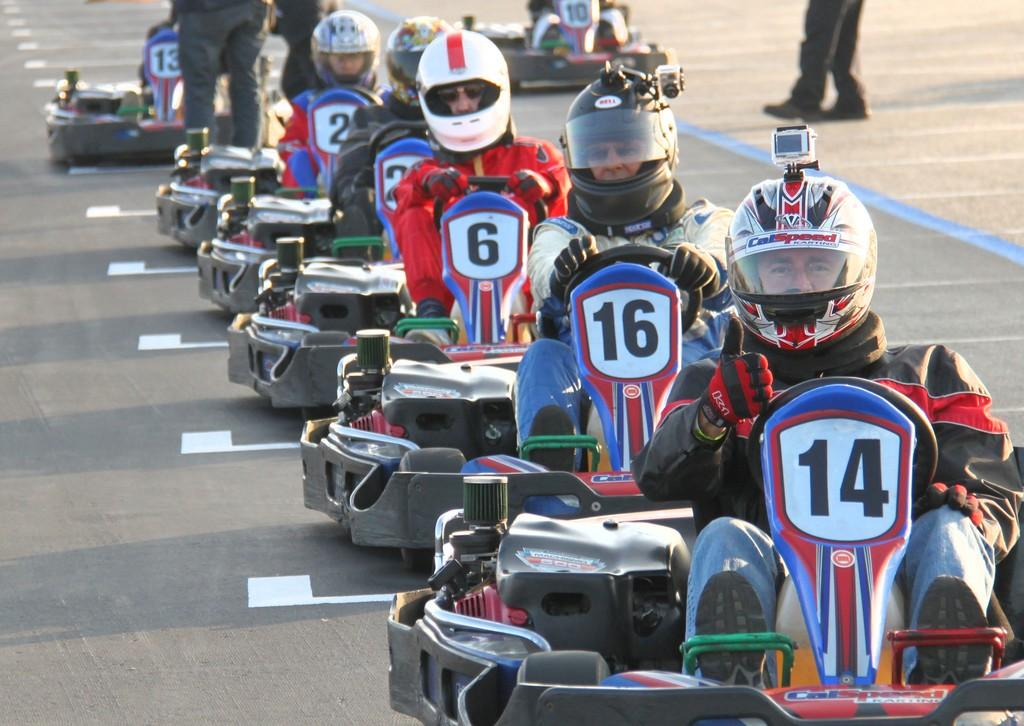What are the people in the image doing? The people in the image are sitting on go-karts. What safety precautions are the people taking while riding the go-karts? The people are wearing helmets. Where are the go-karts located in the image? The go-karts are on a road. What can be seen in the background of the image? There are people standing in the background of the image. What type of goose is leading the army in the image? There is no goose or army present in the image; it features people riding go-karts on a road. How does the person riding the go-kart in the image suppress their cough? There is no mention of a cough in the image, and the focus is on the people riding go-karts and wearing helmets. 